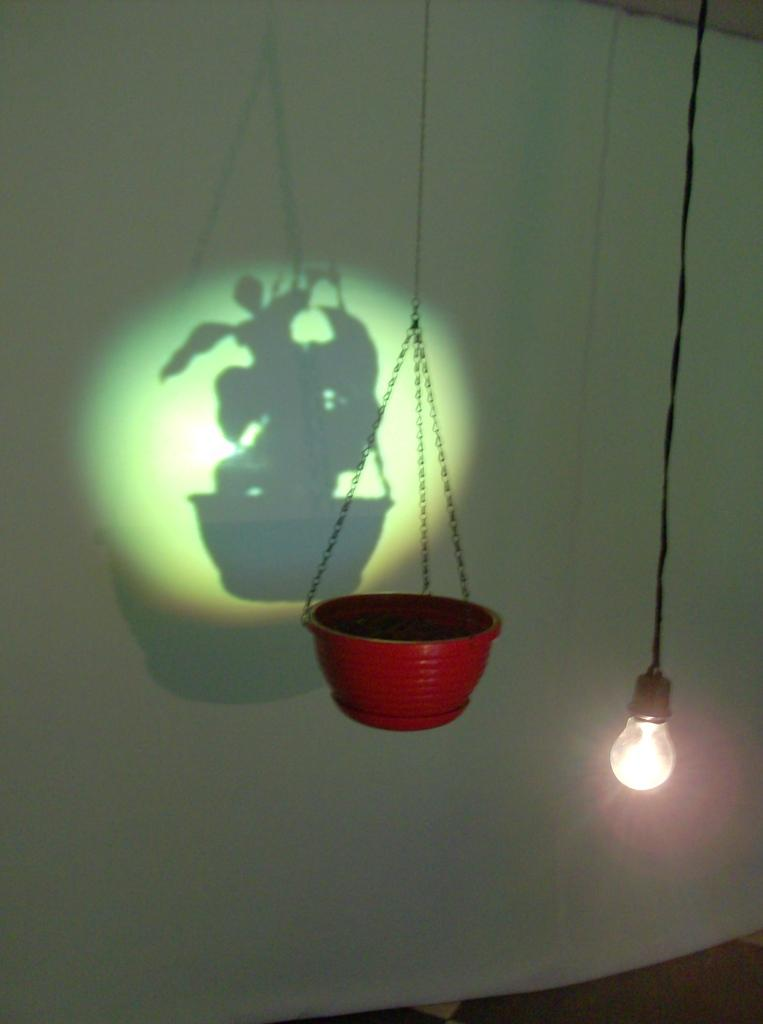What object is the main focus of the image? There is a pot in the image. What can be seen hanging in the image? A light is hanging in the image. What type of shadow is visible in the background of the image? There is a shadow of a flower pot in the background of the image. On what surface is the shadow cast? The shadow is on a white cloth. What type of squirrel can be seen interacting with the pot in the image? There is no squirrel present in the image; it only features a pot, a light, and a shadow of a flower pot. How does the stranger in the image affect the light hanging above the pot? There is no stranger present in the image, so their effect on the light cannot be determined. 